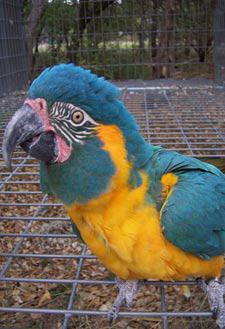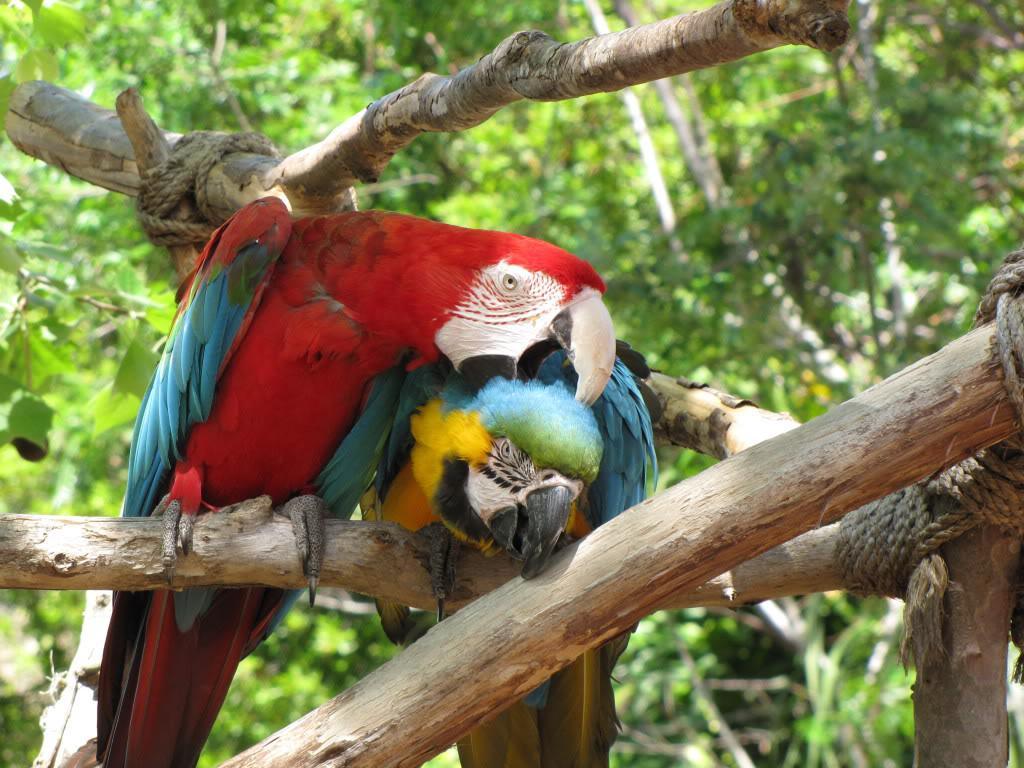The first image is the image on the left, the second image is the image on the right. Considering the images on both sides, is "A single blue and yellow bird is perched in one of the images." valid? Answer yes or no. Yes. The first image is the image on the left, the second image is the image on the right. Examine the images to the left and right. Is the description "The left image contains exactly two parrots." accurate? Answer yes or no. No. 